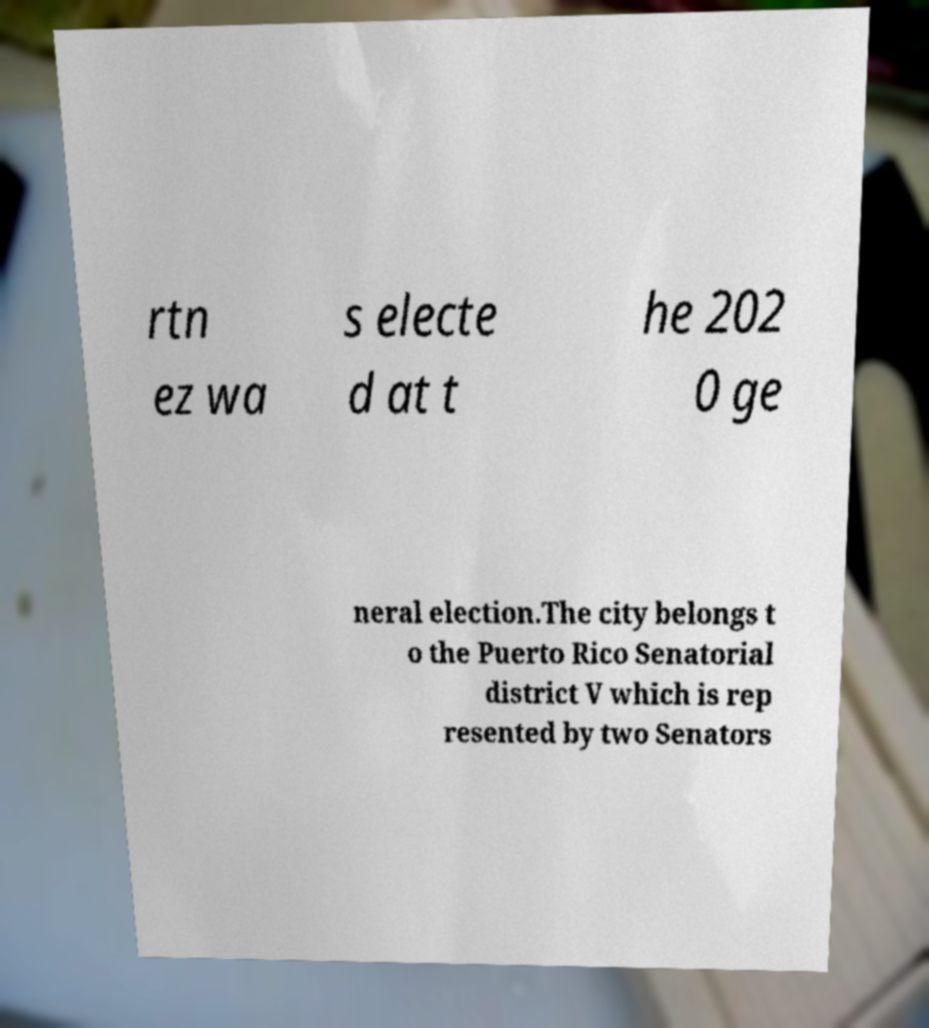I need the written content from this picture converted into text. Can you do that? rtn ez wa s electe d at t he 202 0 ge neral election.The city belongs t o the Puerto Rico Senatorial district V which is rep resented by two Senators 